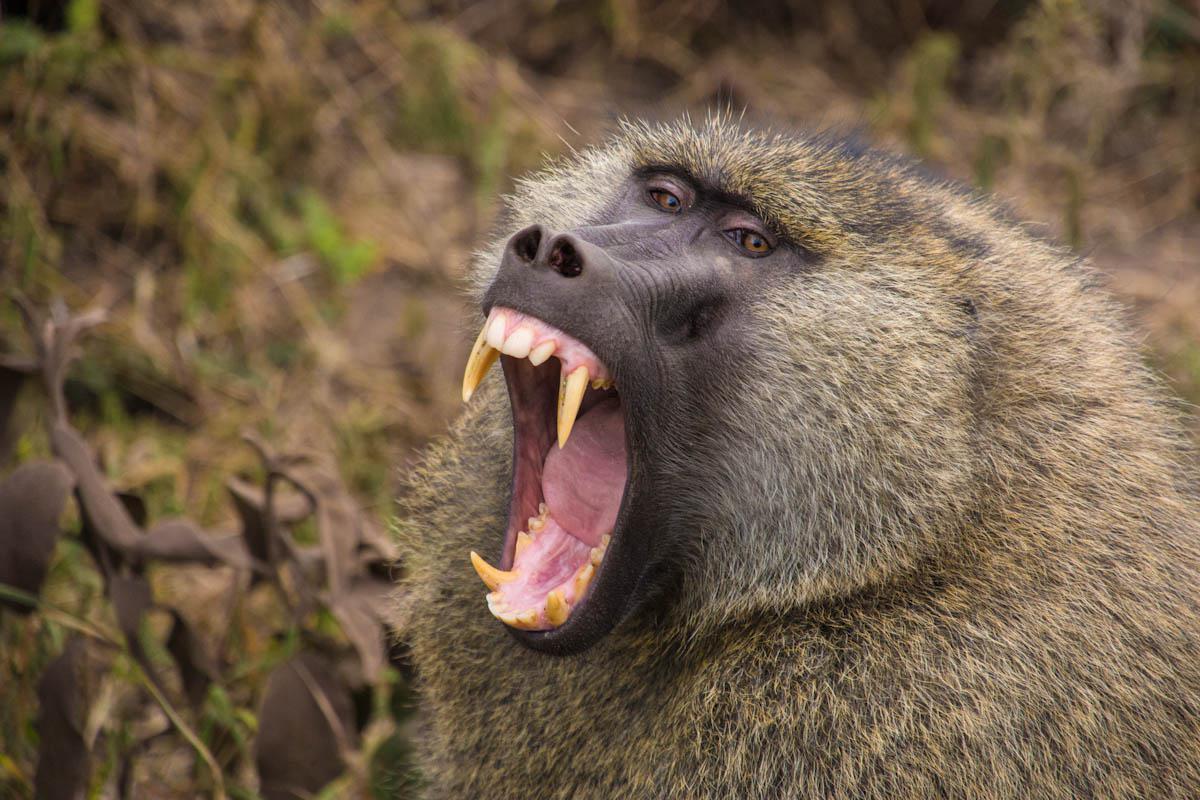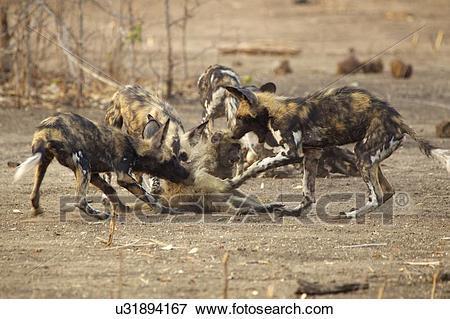The first image is the image on the left, the second image is the image on the right. Analyze the images presented: Is the assertion "At least one of the images contains a baby monkey." valid? Answer yes or no. No. The first image is the image on the left, the second image is the image on the right. Analyze the images presented: Is the assertion "An image containing no more than 3 apes includes a young baboon riding on an adult baboon." valid? Answer yes or no. No. 